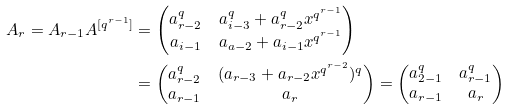Convert formula to latex. <formula><loc_0><loc_0><loc_500><loc_500>A _ { r } = A _ { r - 1 } A ^ { [ q ^ { r - 1 } ] } & = \begin{pmatrix} a ^ { q } _ { r - 2 } & a ^ { q } _ { i - 3 } + a ^ { q } _ { r - 2 } x ^ { q ^ { r - 1 } } \\ a _ { i - 1 } & a _ { a - 2 } + a _ { i - 1 } x ^ { q ^ { r - 1 } } \end{pmatrix} \\ & = \begin{pmatrix} a ^ { q } _ { r - 2 } & ( a _ { r - 3 } + a _ { r - 2 } x ^ { q ^ { r - 2 } } ) ^ { q } \\ a _ { r - 1 } & a _ { r } \end{pmatrix} = \begin{pmatrix} a ^ { q } _ { 2 - 1 } & a ^ { q } _ { r - 1 } \\ a _ { r - 1 } & a _ { r } \end{pmatrix}</formula> 